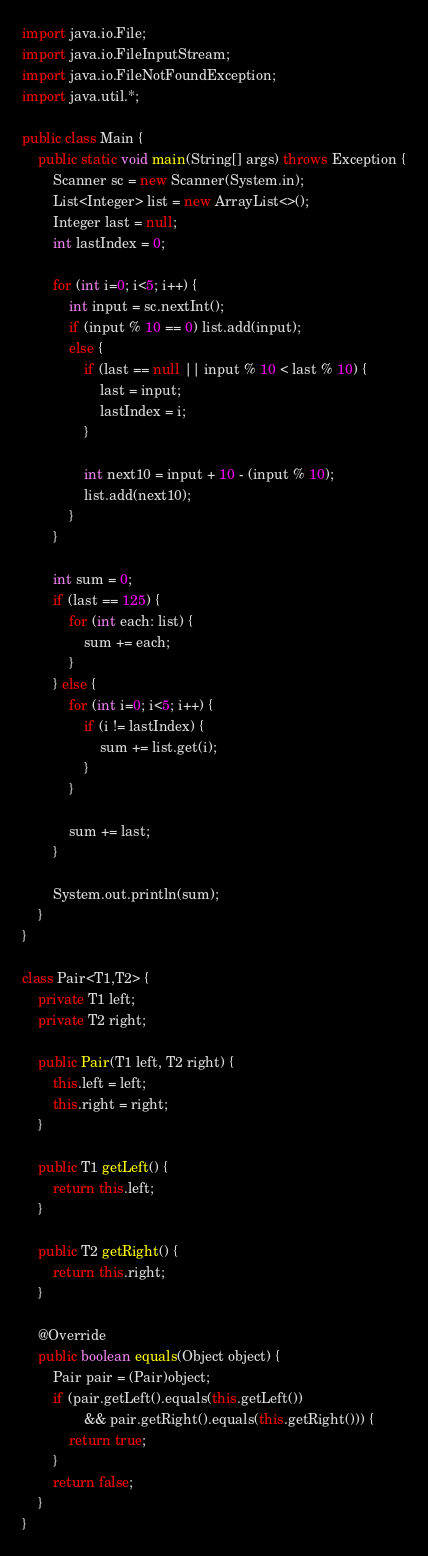<code> <loc_0><loc_0><loc_500><loc_500><_Java_>import java.io.File;
import java.io.FileInputStream;
import java.io.FileNotFoundException;
import java.util.*;

public class Main {
    public static void main(String[] args) throws Exception {
        Scanner sc = new Scanner(System.in);
        List<Integer> list = new ArrayList<>();
        Integer last = null;
        int lastIndex = 0;

        for (int i=0; i<5; i++) {
            int input = sc.nextInt();
            if (input % 10 == 0) list.add(input);
            else {
                if (last == null || input % 10 < last % 10) {
                    last = input;
                    lastIndex = i;
                }

                int next10 = input + 10 - (input % 10);
                list.add(next10);
            }
        }

        int sum = 0;
        if (last == 125) {
            for (int each: list) {
                sum += each;
            }
        } else {
            for (int i=0; i<5; i++) {
                if (i != lastIndex) {
                    sum += list.get(i);
                }
            }

            sum += last;
        }

        System.out.println(sum);
    }
}

class Pair<T1,T2> {
    private T1 left;
    private T2 right;

    public Pair(T1 left, T2 right) {
        this.left = left;
        this.right = right;
    }

    public T1 getLeft() {
        return this.left;
    }

    public T2 getRight() {
        return this.right;
    }

    @Override
    public boolean equals(Object object) {
        Pair pair = (Pair)object;
        if (pair.getLeft().equals(this.getLeft())
                && pair.getRight().equals(this.getRight())) {
            return true;
        }
        return false;
    }
}
</code> 